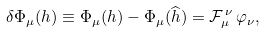Convert formula to latex. <formula><loc_0><loc_0><loc_500><loc_500>\delta \Phi _ { \mu } ( h ) \equiv \Phi _ { \mu } ( h ) - \Phi _ { \mu } ( { \widehat { h } } ) = { \mathcal { F } } _ { \mu } ^ { \, \nu } \, \varphi _ { \nu } ,</formula> 